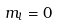Convert formula to latex. <formula><loc_0><loc_0><loc_500><loc_500>m _ { l } = 0</formula> 